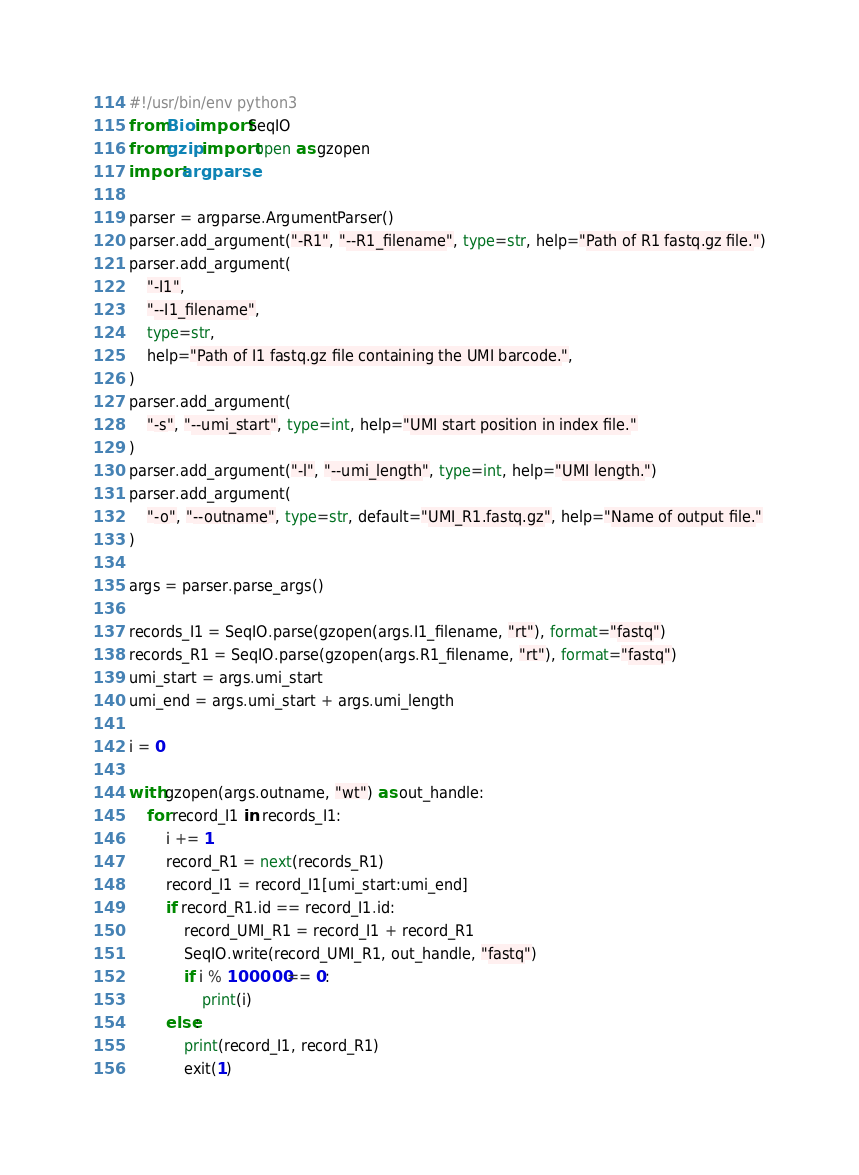<code> <loc_0><loc_0><loc_500><loc_500><_Python_>#!/usr/bin/env python3
from Bio import SeqIO
from gzip import open as gzopen
import argparse

parser = argparse.ArgumentParser()
parser.add_argument("-R1", "--R1_filename", type=str, help="Path of R1 fastq.gz file.")
parser.add_argument(
    "-I1",
    "--I1_filename",
    type=str,
    help="Path of I1 fastq.gz file containing the UMI barcode.",
)
parser.add_argument(
    "-s", "--umi_start", type=int, help="UMI start position in index file."
)
parser.add_argument("-l", "--umi_length", type=int, help="UMI length.")
parser.add_argument(
    "-o", "--outname", type=str, default="UMI_R1.fastq.gz", help="Name of output file."
)

args = parser.parse_args()

records_I1 = SeqIO.parse(gzopen(args.I1_filename, "rt"), format="fastq")
records_R1 = SeqIO.parse(gzopen(args.R1_filename, "rt"), format="fastq")
umi_start = args.umi_start
umi_end = args.umi_start + args.umi_length

i = 0

with gzopen(args.outname, "wt") as out_handle:
    for record_I1 in records_I1:
        i += 1
        record_R1 = next(records_R1)
        record_I1 = record_I1[umi_start:umi_end]
        if record_R1.id == record_I1.id:
            record_UMI_R1 = record_I1 + record_R1
            SeqIO.write(record_UMI_R1, out_handle, "fastq")
            if i % 100000 == 0:
                print(i)
        else:
            print(record_I1, record_R1)
            exit(1)
</code> 